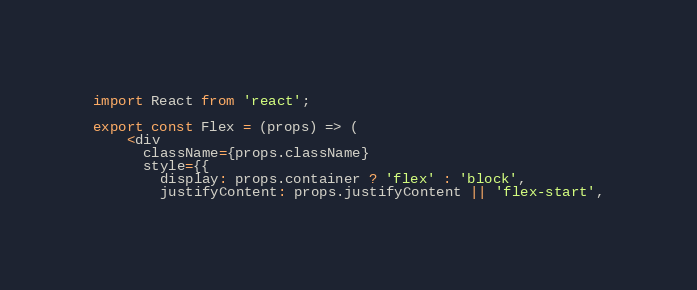<code> <loc_0><loc_0><loc_500><loc_500><_JavaScript_>import React from 'react';

export const Flex = (props) => (
    <div
      className={props.className}
      style={{
        display: props.container ? 'flex' : 'block',
        justifyContent: props.justifyContent || 'flex-start',</code> 